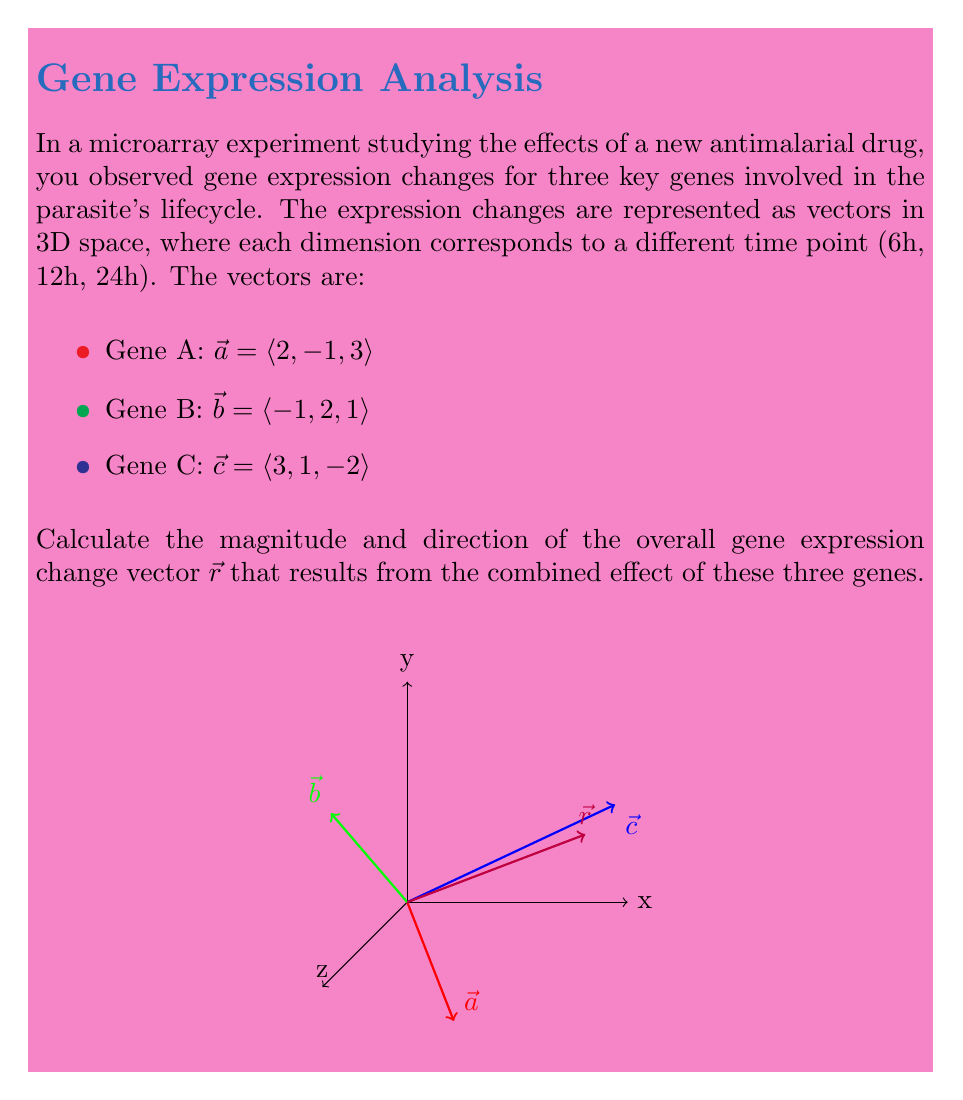Help me with this question. To solve this problem, we'll follow these steps:

1) First, we need to find the resultant vector $\vec{r}$ by adding the three gene expression vectors:

   $\vec{r} = \vec{a} + \vec{b} + \vec{c}$
   $= \langle 2, -1, 3 \rangle + \langle -1, 2, 1 \rangle + \langle 3, 1, -2 \rangle$
   $= \langle 2-1+3, -1+2+1, 3+1-2 \rangle$
   $= \langle 4, 2, 2 \rangle$

2) To find the magnitude of $\vec{r}$, we use the formula:

   $|\vec{r}| = \sqrt{x^2 + y^2 + z^2}$

   Where $x$, $y$, and $z$ are the components of $\vec{r}$.

   $|\vec{r}| = \sqrt{4^2 + 2^2 + 2^2}$
   $= \sqrt{16 + 4 + 4}$
   $= \sqrt{24}$
   $= 2\sqrt{6}$

3) To find the direction of $\vec{r}$, we need to calculate the unit vector $\hat{r}$:

   $\hat{r} = \frac{\vec{r}}{|\vec{r}|} = \frac{\langle 4, 2, 2 \rangle}{2\sqrt{6}}$

   $= \langle \frac{2}{\sqrt{6}}, \frac{1}{\sqrt{6}}, \frac{1}{\sqrt{6}} \rangle$

This unit vector represents the direction of the overall gene expression change.
Answer: Magnitude: $2\sqrt{6}$, Direction: $\langle \frac{2}{\sqrt{6}}, \frac{1}{\sqrt{6}}, \frac{1}{\sqrt{6}} \rangle$ 